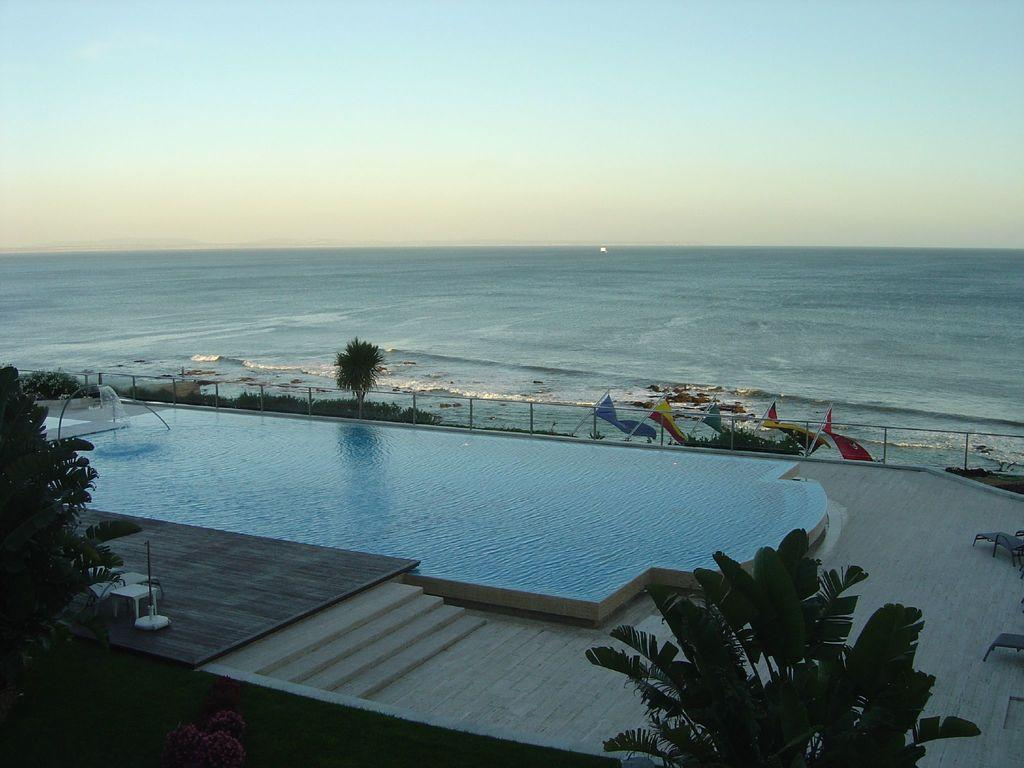What can be seen in the center of the image? The sky, water, trees, flags, a fence, and a swimming pool can be seen in the center of the image. How many elements are present in the center of the image? There are six elements present in the center of the image: sky, water, trees, flags, a fence, and a swimming pool. What type of natural feature is visible in the center of the image? Trees are a type of natural feature visible in the center of the image. What type of attention is being given to the dinner in the image? There is no dinner present in the image, so it is not possible to determine what type of attention is being given to it. What type of drink is being served in the image? There is no drink present in the image, so it is not possible to determine what type of drink is being served. 